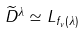<formula> <loc_0><loc_0><loc_500><loc_500>\widetilde { D } ^ { \lambda } \simeq L _ { f _ { v } ( { \lambda } ) }</formula> 